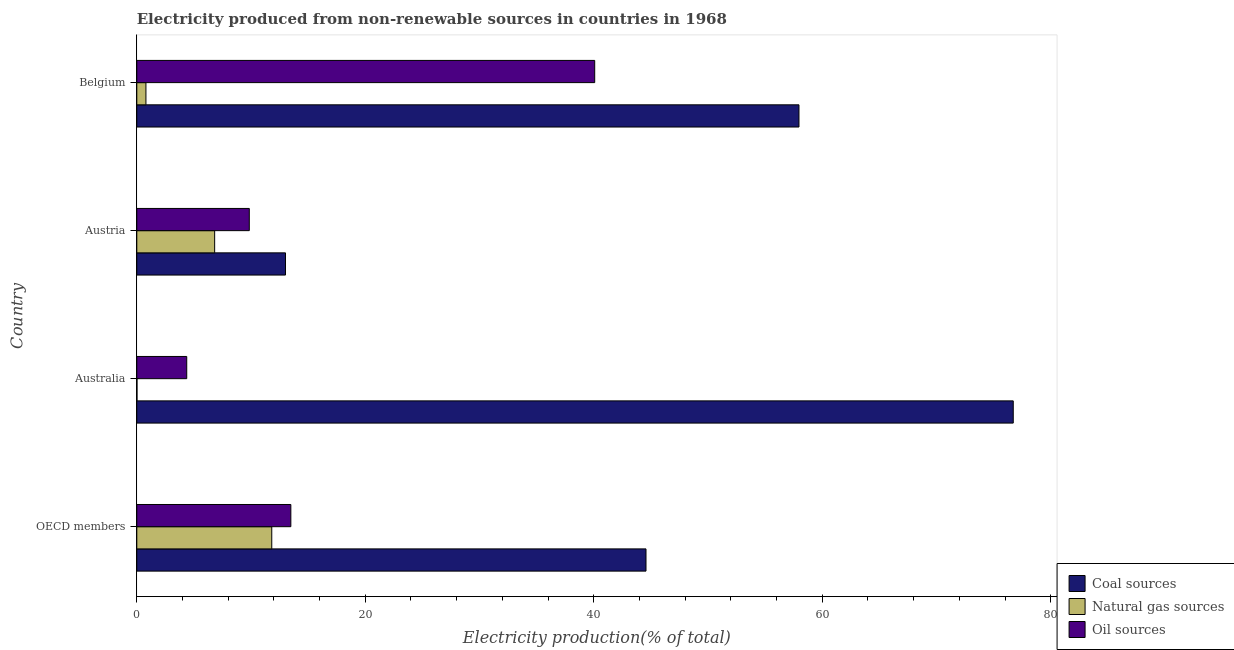How many groups of bars are there?
Give a very brief answer. 4. How many bars are there on the 2nd tick from the bottom?
Provide a short and direct response. 3. What is the percentage of electricity produced by coal in Austria?
Ensure brevity in your answer.  13.02. Across all countries, what is the maximum percentage of electricity produced by natural gas?
Give a very brief answer. 11.82. Across all countries, what is the minimum percentage of electricity produced by oil sources?
Offer a very short reply. 4.37. What is the total percentage of electricity produced by oil sources in the graph?
Provide a short and direct response. 67.79. What is the difference between the percentage of electricity produced by coal in Australia and that in Belgium?
Your response must be concise. 18.76. What is the difference between the percentage of electricity produced by oil sources in Austria and the percentage of electricity produced by coal in OECD members?
Provide a short and direct response. -34.73. What is the average percentage of electricity produced by oil sources per country?
Your response must be concise. 16.95. What is the difference between the percentage of electricity produced by natural gas and percentage of electricity produced by oil sources in Austria?
Make the answer very short. -3.03. What is the ratio of the percentage of electricity produced by natural gas in Belgium to that in OECD members?
Your response must be concise. 0.07. Is the difference between the percentage of electricity produced by oil sources in Austria and OECD members greater than the difference between the percentage of electricity produced by coal in Austria and OECD members?
Your answer should be compact. Yes. What is the difference between the highest and the second highest percentage of electricity produced by oil sources?
Provide a succinct answer. 26.6. What is the difference between the highest and the lowest percentage of electricity produced by oil sources?
Your response must be concise. 35.71. What does the 1st bar from the top in Austria represents?
Ensure brevity in your answer.  Oil sources. What does the 3rd bar from the bottom in Australia represents?
Your answer should be very brief. Oil sources. How many bars are there?
Give a very brief answer. 12. Are all the bars in the graph horizontal?
Ensure brevity in your answer.  Yes. Does the graph contain any zero values?
Give a very brief answer. No. How many legend labels are there?
Your answer should be compact. 3. How are the legend labels stacked?
Offer a terse response. Vertical. What is the title of the graph?
Offer a very short reply. Electricity produced from non-renewable sources in countries in 1968. What is the label or title of the X-axis?
Your response must be concise. Electricity production(% of total). What is the label or title of the Y-axis?
Your answer should be compact. Country. What is the Electricity production(% of total) of Coal sources in OECD members?
Your response must be concise. 44.57. What is the Electricity production(% of total) of Natural gas sources in OECD members?
Give a very brief answer. 11.82. What is the Electricity production(% of total) in Oil sources in OECD members?
Make the answer very short. 13.48. What is the Electricity production(% of total) in Coal sources in Australia?
Provide a succinct answer. 76.72. What is the Electricity production(% of total) in Natural gas sources in Australia?
Your answer should be very brief. 0.02. What is the Electricity production(% of total) in Oil sources in Australia?
Give a very brief answer. 4.37. What is the Electricity production(% of total) of Coal sources in Austria?
Make the answer very short. 13.02. What is the Electricity production(% of total) in Natural gas sources in Austria?
Offer a terse response. 6.82. What is the Electricity production(% of total) in Oil sources in Austria?
Make the answer very short. 9.85. What is the Electricity production(% of total) of Coal sources in Belgium?
Provide a short and direct response. 57.96. What is the Electricity production(% of total) of Natural gas sources in Belgium?
Provide a succinct answer. 0.8. What is the Electricity production(% of total) in Oil sources in Belgium?
Offer a very short reply. 40.08. Across all countries, what is the maximum Electricity production(% of total) in Coal sources?
Provide a succinct answer. 76.72. Across all countries, what is the maximum Electricity production(% of total) of Natural gas sources?
Your response must be concise. 11.82. Across all countries, what is the maximum Electricity production(% of total) of Oil sources?
Give a very brief answer. 40.08. Across all countries, what is the minimum Electricity production(% of total) of Coal sources?
Provide a succinct answer. 13.02. Across all countries, what is the minimum Electricity production(% of total) in Natural gas sources?
Offer a terse response. 0.02. Across all countries, what is the minimum Electricity production(% of total) of Oil sources?
Provide a short and direct response. 4.37. What is the total Electricity production(% of total) in Coal sources in the graph?
Provide a succinct answer. 192.28. What is the total Electricity production(% of total) of Natural gas sources in the graph?
Offer a terse response. 19.45. What is the total Electricity production(% of total) in Oil sources in the graph?
Your response must be concise. 67.79. What is the difference between the Electricity production(% of total) of Coal sources in OECD members and that in Australia?
Your answer should be compact. -32.15. What is the difference between the Electricity production(% of total) in Natural gas sources in OECD members and that in Australia?
Your answer should be compact. 11.8. What is the difference between the Electricity production(% of total) of Oil sources in OECD members and that in Australia?
Provide a succinct answer. 9.11. What is the difference between the Electricity production(% of total) in Coal sources in OECD members and that in Austria?
Make the answer very short. 31.56. What is the difference between the Electricity production(% of total) in Natural gas sources in OECD members and that in Austria?
Provide a succinct answer. 5. What is the difference between the Electricity production(% of total) in Oil sources in OECD members and that in Austria?
Your answer should be very brief. 3.64. What is the difference between the Electricity production(% of total) of Coal sources in OECD members and that in Belgium?
Give a very brief answer. -13.39. What is the difference between the Electricity production(% of total) of Natural gas sources in OECD members and that in Belgium?
Offer a terse response. 11.01. What is the difference between the Electricity production(% of total) of Oil sources in OECD members and that in Belgium?
Offer a terse response. -26.6. What is the difference between the Electricity production(% of total) of Coal sources in Australia and that in Austria?
Provide a succinct answer. 63.7. What is the difference between the Electricity production(% of total) in Natural gas sources in Australia and that in Austria?
Offer a terse response. -6.8. What is the difference between the Electricity production(% of total) in Oil sources in Australia and that in Austria?
Make the answer very short. -5.48. What is the difference between the Electricity production(% of total) in Coal sources in Australia and that in Belgium?
Your answer should be very brief. 18.76. What is the difference between the Electricity production(% of total) of Natural gas sources in Australia and that in Belgium?
Keep it short and to the point. -0.78. What is the difference between the Electricity production(% of total) in Oil sources in Australia and that in Belgium?
Your answer should be very brief. -35.71. What is the difference between the Electricity production(% of total) in Coal sources in Austria and that in Belgium?
Offer a very short reply. -44.95. What is the difference between the Electricity production(% of total) in Natural gas sources in Austria and that in Belgium?
Provide a short and direct response. 6.02. What is the difference between the Electricity production(% of total) of Oil sources in Austria and that in Belgium?
Ensure brevity in your answer.  -30.23. What is the difference between the Electricity production(% of total) in Coal sources in OECD members and the Electricity production(% of total) in Natural gas sources in Australia?
Your response must be concise. 44.56. What is the difference between the Electricity production(% of total) of Coal sources in OECD members and the Electricity production(% of total) of Oil sources in Australia?
Offer a very short reply. 40.2. What is the difference between the Electricity production(% of total) of Natural gas sources in OECD members and the Electricity production(% of total) of Oil sources in Australia?
Ensure brevity in your answer.  7.44. What is the difference between the Electricity production(% of total) of Coal sources in OECD members and the Electricity production(% of total) of Natural gas sources in Austria?
Your response must be concise. 37.76. What is the difference between the Electricity production(% of total) of Coal sources in OECD members and the Electricity production(% of total) of Oil sources in Austria?
Offer a very short reply. 34.73. What is the difference between the Electricity production(% of total) in Natural gas sources in OECD members and the Electricity production(% of total) in Oil sources in Austria?
Provide a succinct answer. 1.97. What is the difference between the Electricity production(% of total) of Coal sources in OECD members and the Electricity production(% of total) of Natural gas sources in Belgium?
Keep it short and to the point. 43.77. What is the difference between the Electricity production(% of total) of Coal sources in OECD members and the Electricity production(% of total) of Oil sources in Belgium?
Keep it short and to the point. 4.49. What is the difference between the Electricity production(% of total) in Natural gas sources in OECD members and the Electricity production(% of total) in Oil sources in Belgium?
Ensure brevity in your answer.  -28.27. What is the difference between the Electricity production(% of total) of Coal sources in Australia and the Electricity production(% of total) of Natural gas sources in Austria?
Provide a short and direct response. 69.9. What is the difference between the Electricity production(% of total) in Coal sources in Australia and the Electricity production(% of total) in Oil sources in Austria?
Keep it short and to the point. 66.87. What is the difference between the Electricity production(% of total) in Natural gas sources in Australia and the Electricity production(% of total) in Oil sources in Austria?
Provide a succinct answer. -9.83. What is the difference between the Electricity production(% of total) of Coal sources in Australia and the Electricity production(% of total) of Natural gas sources in Belgium?
Keep it short and to the point. 75.92. What is the difference between the Electricity production(% of total) in Coal sources in Australia and the Electricity production(% of total) in Oil sources in Belgium?
Your response must be concise. 36.64. What is the difference between the Electricity production(% of total) of Natural gas sources in Australia and the Electricity production(% of total) of Oil sources in Belgium?
Give a very brief answer. -40.07. What is the difference between the Electricity production(% of total) in Coal sources in Austria and the Electricity production(% of total) in Natural gas sources in Belgium?
Your answer should be very brief. 12.22. What is the difference between the Electricity production(% of total) in Coal sources in Austria and the Electricity production(% of total) in Oil sources in Belgium?
Your answer should be very brief. -27.07. What is the difference between the Electricity production(% of total) of Natural gas sources in Austria and the Electricity production(% of total) of Oil sources in Belgium?
Ensure brevity in your answer.  -33.27. What is the average Electricity production(% of total) in Coal sources per country?
Your answer should be compact. 48.07. What is the average Electricity production(% of total) in Natural gas sources per country?
Ensure brevity in your answer.  4.86. What is the average Electricity production(% of total) of Oil sources per country?
Offer a terse response. 16.95. What is the difference between the Electricity production(% of total) of Coal sources and Electricity production(% of total) of Natural gas sources in OECD members?
Your answer should be very brief. 32.76. What is the difference between the Electricity production(% of total) of Coal sources and Electricity production(% of total) of Oil sources in OECD members?
Keep it short and to the point. 31.09. What is the difference between the Electricity production(% of total) in Natural gas sources and Electricity production(% of total) in Oil sources in OECD members?
Provide a succinct answer. -1.67. What is the difference between the Electricity production(% of total) of Coal sources and Electricity production(% of total) of Natural gas sources in Australia?
Ensure brevity in your answer.  76.7. What is the difference between the Electricity production(% of total) of Coal sources and Electricity production(% of total) of Oil sources in Australia?
Make the answer very short. 72.35. What is the difference between the Electricity production(% of total) in Natural gas sources and Electricity production(% of total) in Oil sources in Australia?
Provide a succinct answer. -4.36. What is the difference between the Electricity production(% of total) of Coal sources and Electricity production(% of total) of Natural gas sources in Austria?
Offer a very short reply. 6.2. What is the difference between the Electricity production(% of total) of Coal sources and Electricity production(% of total) of Oil sources in Austria?
Offer a terse response. 3.17. What is the difference between the Electricity production(% of total) in Natural gas sources and Electricity production(% of total) in Oil sources in Austria?
Your answer should be compact. -3.03. What is the difference between the Electricity production(% of total) in Coal sources and Electricity production(% of total) in Natural gas sources in Belgium?
Provide a short and direct response. 57.16. What is the difference between the Electricity production(% of total) in Coal sources and Electricity production(% of total) in Oil sources in Belgium?
Provide a short and direct response. 17.88. What is the difference between the Electricity production(% of total) in Natural gas sources and Electricity production(% of total) in Oil sources in Belgium?
Offer a very short reply. -39.28. What is the ratio of the Electricity production(% of total) in Coal sources in OECD members to that in Australia?
Provide a succinct answer. 0.58. What is the ratio of the Electricity production(% of total) in Natural gas sources in OECD members to that in Australia?
Your response must be concise. 704.91. What is the ratio of the Electricity production(% of total) of Oil sources in OECD members to that in Australia?
Provide a short and direct response. 3.08. What is the ratio of the Electricity production(% of total) in Coal sources in OECD members to that in Austria?
Your answer should be very brief. 3.42. What is the ratio of the Electricity production(% of total) in Natural gas sources in OECD members to that in Austria?
Make the answer very short. 1.73. What is the ratio of the Electricity production(% of total) in Oil sources in OECD members to that in Austria?
Your answer should be compact. 1.37. What is the ratio of the Electricity production(% of total) in Coal sources in OECD members to that in Belgium?
Offer a very short reply. 0.77. What is the ratio of the Electricity production(% of total) of Natural gas sources in OECD members to that in Belgium?
Make the answer very short. 14.75. What is the ratio of the Electricity production(% of total) in Oil sources in OECD members to that in Belgium?
Offer a terse response. 0.34. What is the ratio of the Electricity production(% of total) of Coal sources in Australia to that in Austria?
Your answer should be compact. 5.89. What is the ratio of the Electricity production(% of total) in Natural gas sources in Australia to that in Austria?
Provide a short and direct response. 0. What is the ratio of the Electricity production(% of total) in Oil sources in Australia to that in Austria?
Offer a very short reply. 0.44. What is the ratio of the Electricity production(% of total) in Coal sources in Australia to that in Belgium?
Your answer should be compact. 1.32. What is the ratio of the Electricity production(% of total) in Natural gas sources in Australia to that in Belgium?
Provide a short and direct response. 0.02. What is the ratio of the Electricity production(% of total) in Oil sources in Australia to that in Belgium?
Provide a succinct answer. 0.11. What is the ratio of the Electricity production(% of total) in Coal sources in Austria to that in Belgium?
Provide a short and direct response. 0.22. What is the ratio of the Electricity production(% of total) of Natural gas sources in Austria to that in Belgium?
Provide a succinct answer. 8.51. What is the ratio of the Electricity production(% of total) of Oil sources in Austria to that in Belgium?
Offer a terse response. 0.25. What is the difference between the highest and the second highest Electricity production(% of total) in Coal sources?
Offer a terse response. 18.76. What is the difference between the highest and the second highest Electricity production(% of total) of Natural gas sources?
Your answer should be very brief. 5. What is the difference between the highest and the second highest Electricity production(% of total) in Oil sources?
Keep it short and to the point. 26.6. What is the difference between the highest and the lowest Electricity production(% of total) of Coal sources?
Your response must be concise. 63.7. What is the difference between the highest and the lowest Electricity production(% of total) in Natural gas sources?
Provide a succinct answer. 11.8. What is the difference between the highest and the lowest Electricity production(% of total) of Oil sources?
Offer a terse response. 35.71. 